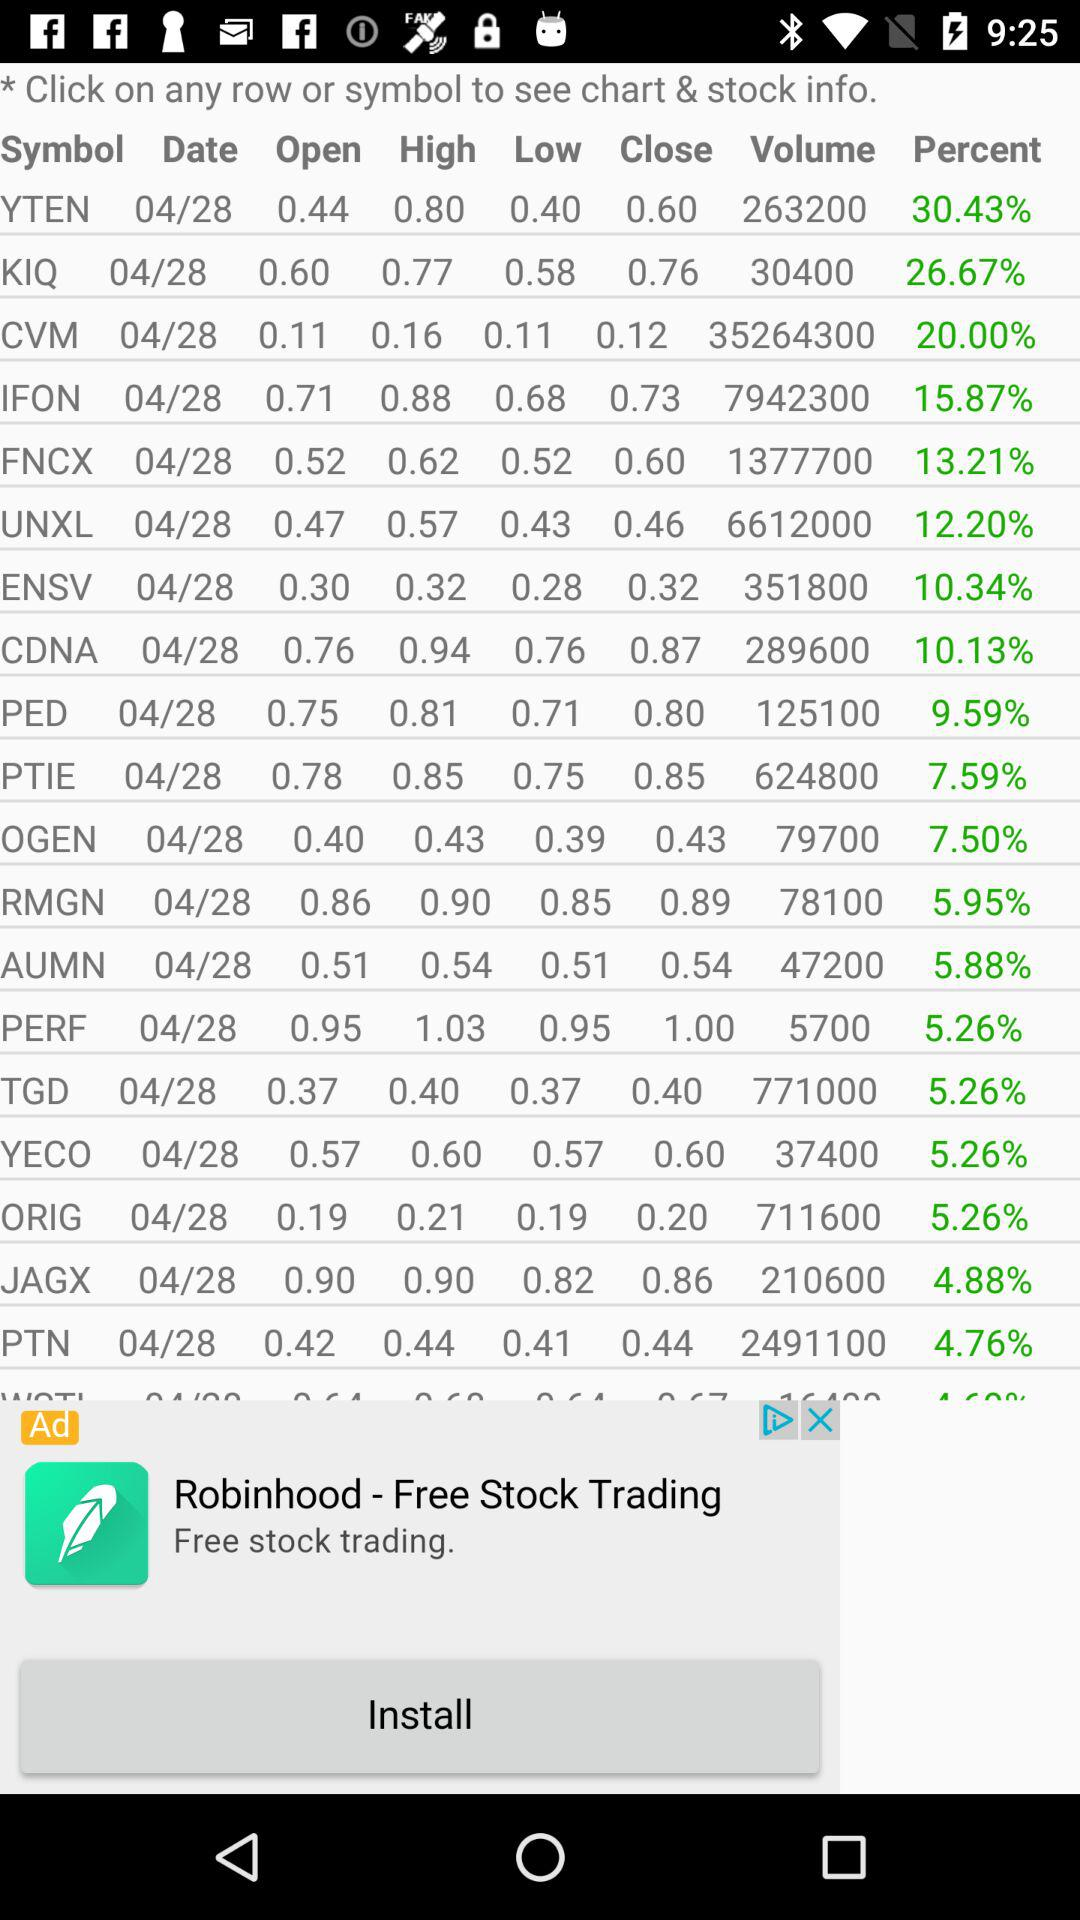What is the open value of "JAGX"? The open value of "JAGX" is 0.90. 